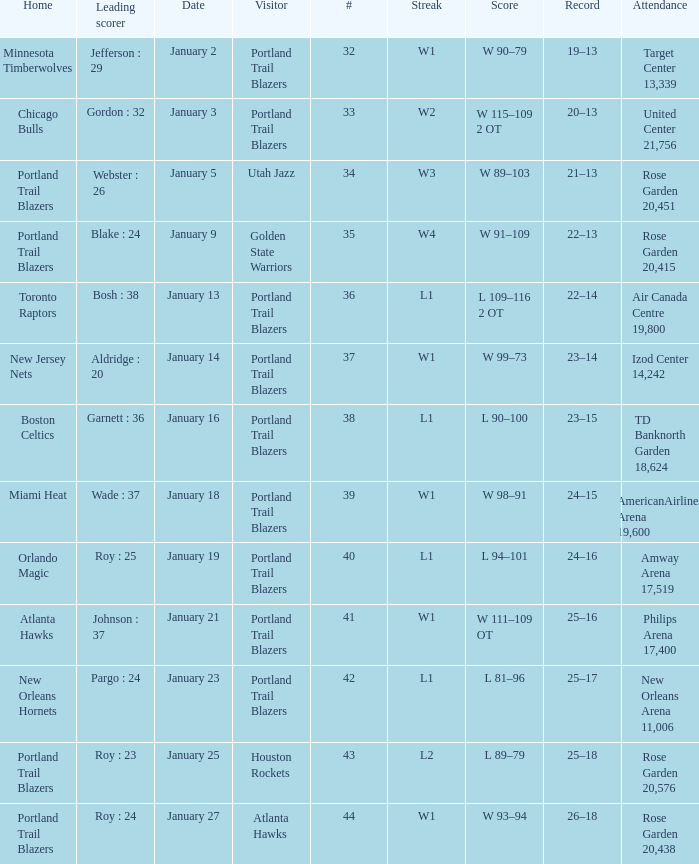What is the total number of dates where the scorer is gordon : 32 1.0. 